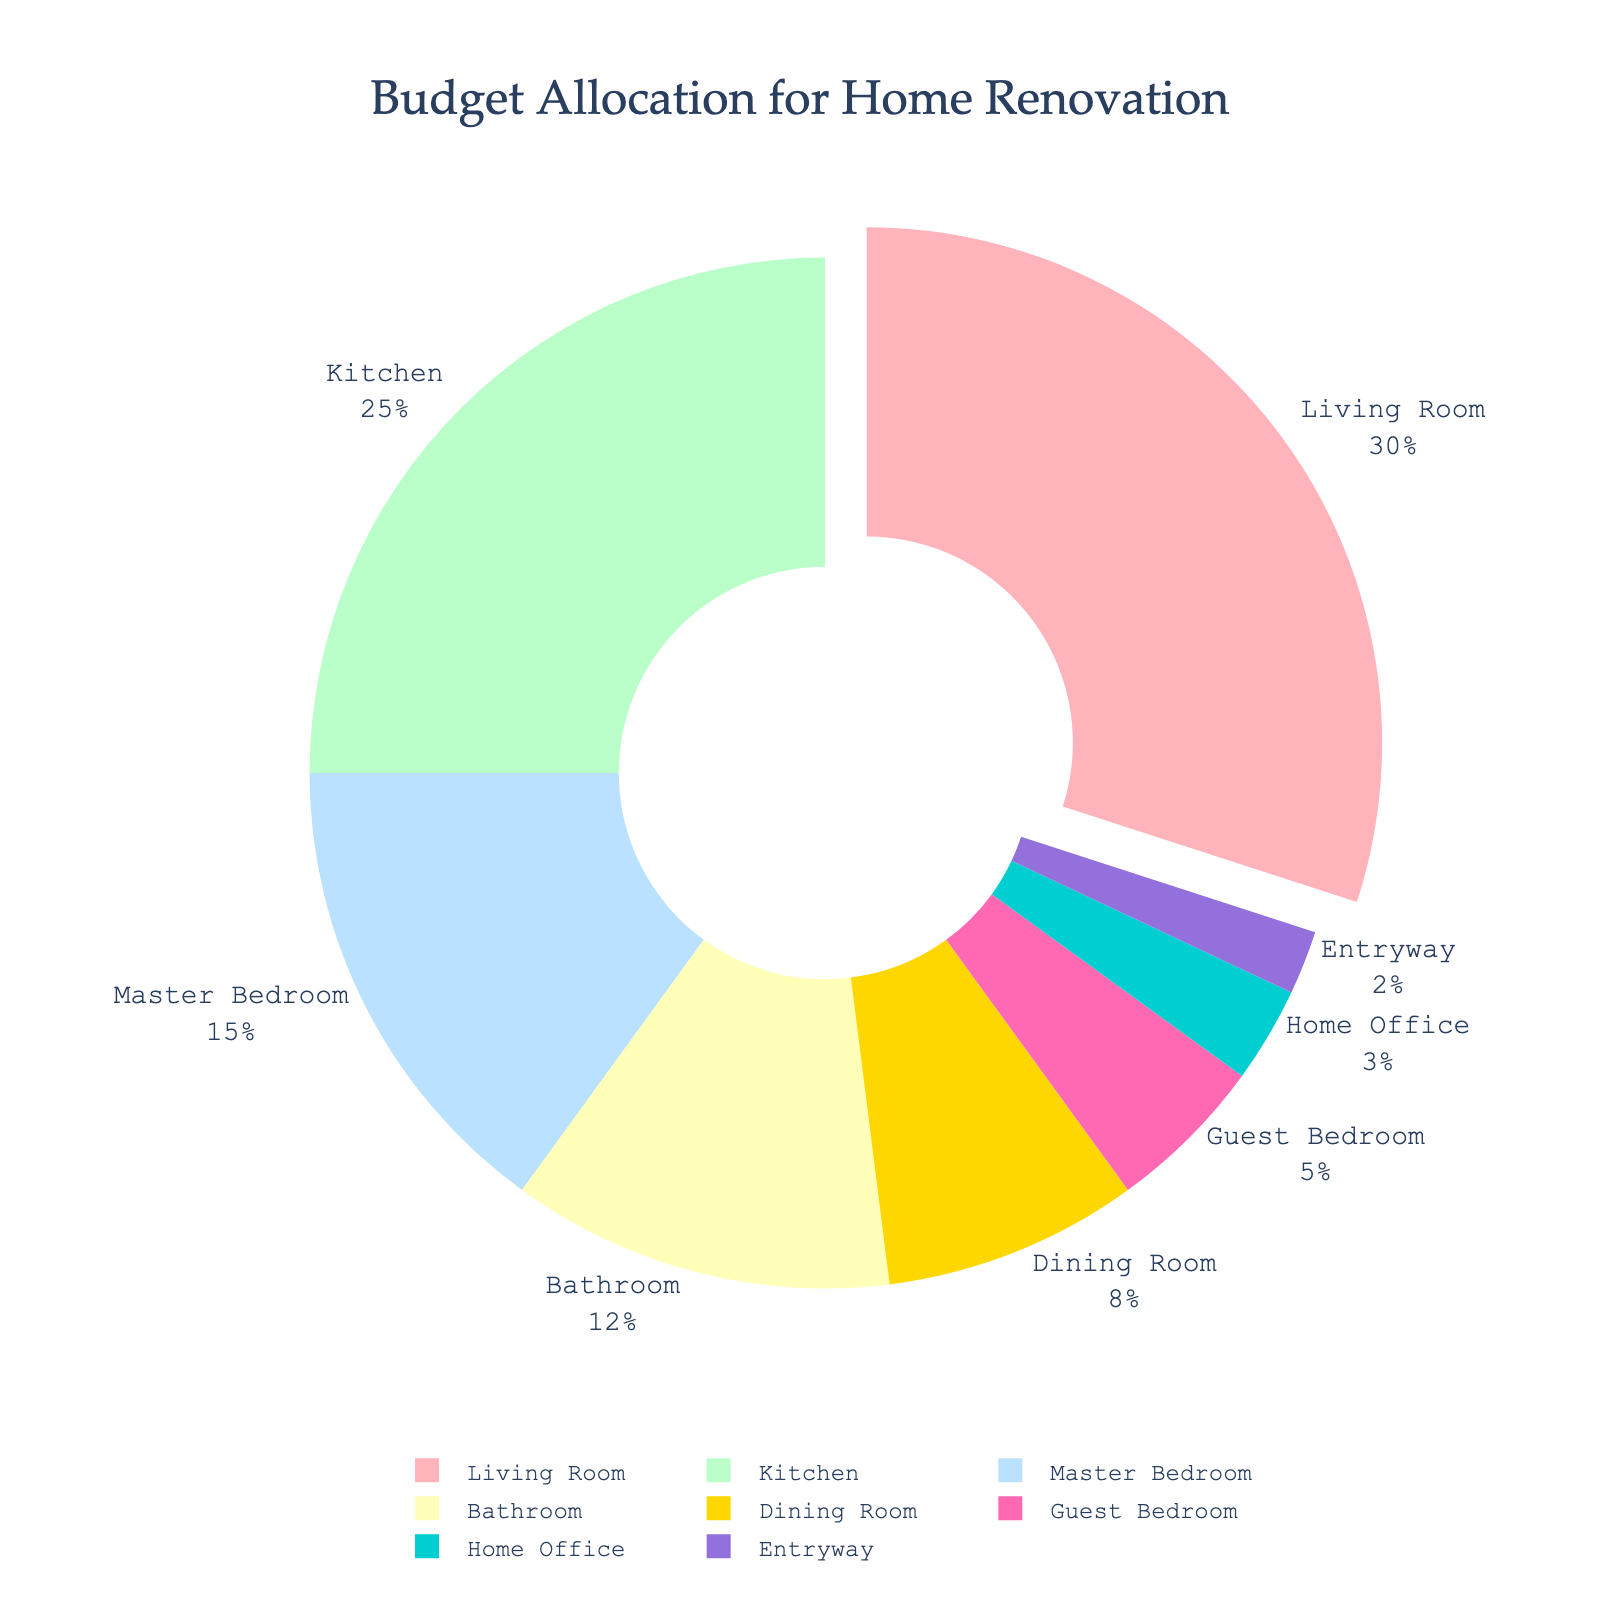What room type gets the most significant portion of the budget allocation? The pie chart highlights which category has the largest percentage. Here, the slice representing the Living Room is the largest.
Answer: Living Room What is the combined budget allocation for the Kitchen and Bathroom? You need to sum the percentages for Kitchen and Bathroom. Refer to their respective slices: Kitchen (25%) and Bathroom (12%). So, 25% + 12% = 37%.
Answer: 37% Which room type has the smallest budget allocation? Look for the smallest slice in the pie chart. The Entryway has the smallest slice, indicating its allocation is the least.
Answer: Entryway Is the budget allocation for the Master Bedroom greater than that of the Guest Bedroom? Compare the slices for the Master Bedroom and Guest Bedroom: Master Bedroom (15%) and Guest Bedroom (5%). The slice for the Master Bedroom is clearly larger.
Answer: Yes How much larger is the budget allocation for the Living Room compared to the Dining Room? Subtract the percentage of the Dining Room from the percentage of the Living Room. Living Room (30%) - Dining Room (8%) = 22%.
Answer: 22% What percentage of the budget is allocated to bedrooms (Master Bedroom and Guest Bedroom combined)? Add the percentages for the Master Bedroom and Guest Bedroom. Refer to their slices: Master Bedroom (15%) and Guest Bedroom (5%). So, 15% + 5% = 20%.
Answer: 20% If you needed to justify your choices based on budget allocation, which room types would you prioritize due to their higher budget allocations? Higher allocations are given to the Living Room (30%) and Kitchen (25%). Prioritize based on these larger slices.
Answer: Living Room and Kitchen What is the visual attribute used to highlight the room type with the highest budget allocation? The slice for the room type with the highest allocation (Living Room) is pulled slightly outside the pie chart to highlight it.
Answer: Pulled-Out Slice Are the combined budget allocations for non-bedroom areas (Living Room, Kitchen, Bathroom, Dining Room, Home Office, and Entryway) greater than 80%? Sum the percentages for these areas: Living Room (30%) + Kitchen (25%) + Bathroom (12%) + Dining Room (8%) + Home Office (3%) + Entryway (2%) = 80%. Hence, they are 80%, not greater.
Answer: No What color represents the slice for the budget allocation of the Home Office? The colors used in the pie chart show the Home Office in a distinct color. It is represented by the cyan color.
Answer: Cyan 